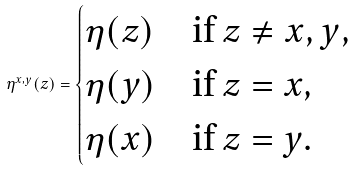<formula> <loc_0><loc_0><loc_500><loc_500>\eta ^ { x , y } ( z ) = \begin{cases} \eta ( z ) & \text {if } z \neq x , y , \\ \eta ( y ) & \text {if } z = x , \\ \eta ( x ) & \text {if } z = y . \end{cases}</formula> 